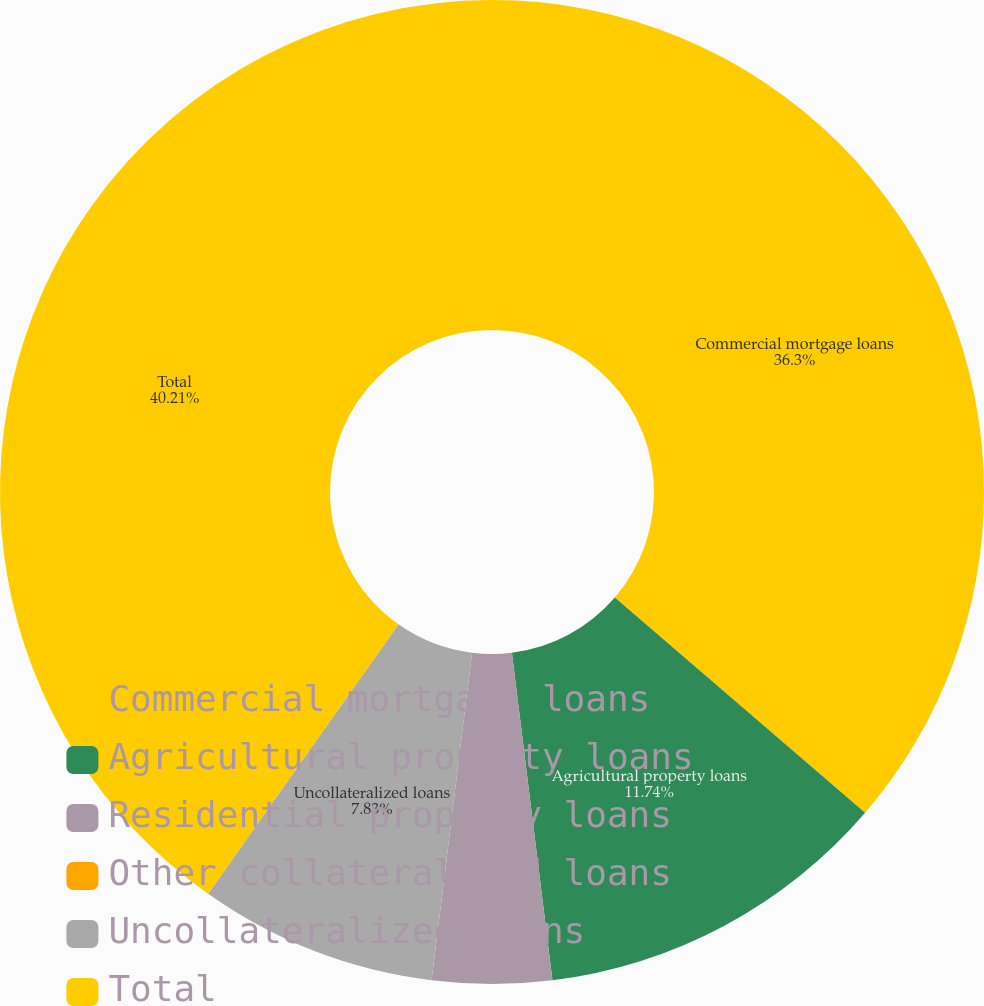Convert chart. <chart><loc_0><loc_0><loc_500><loc_500><pie_chart><fcel>Commercial mortgage loans<fcel>Agricultural property loans<fcel>Residential property loans<fcel>Other collateralized loans<fcel>Uncollateralized loans<fcel>Total<nl><fcel>36.3%<fcel>11.74%<fcel>3.92%<fcel>0.0%<fcel>7.83%<fcel>40.21%<nl></chart> 